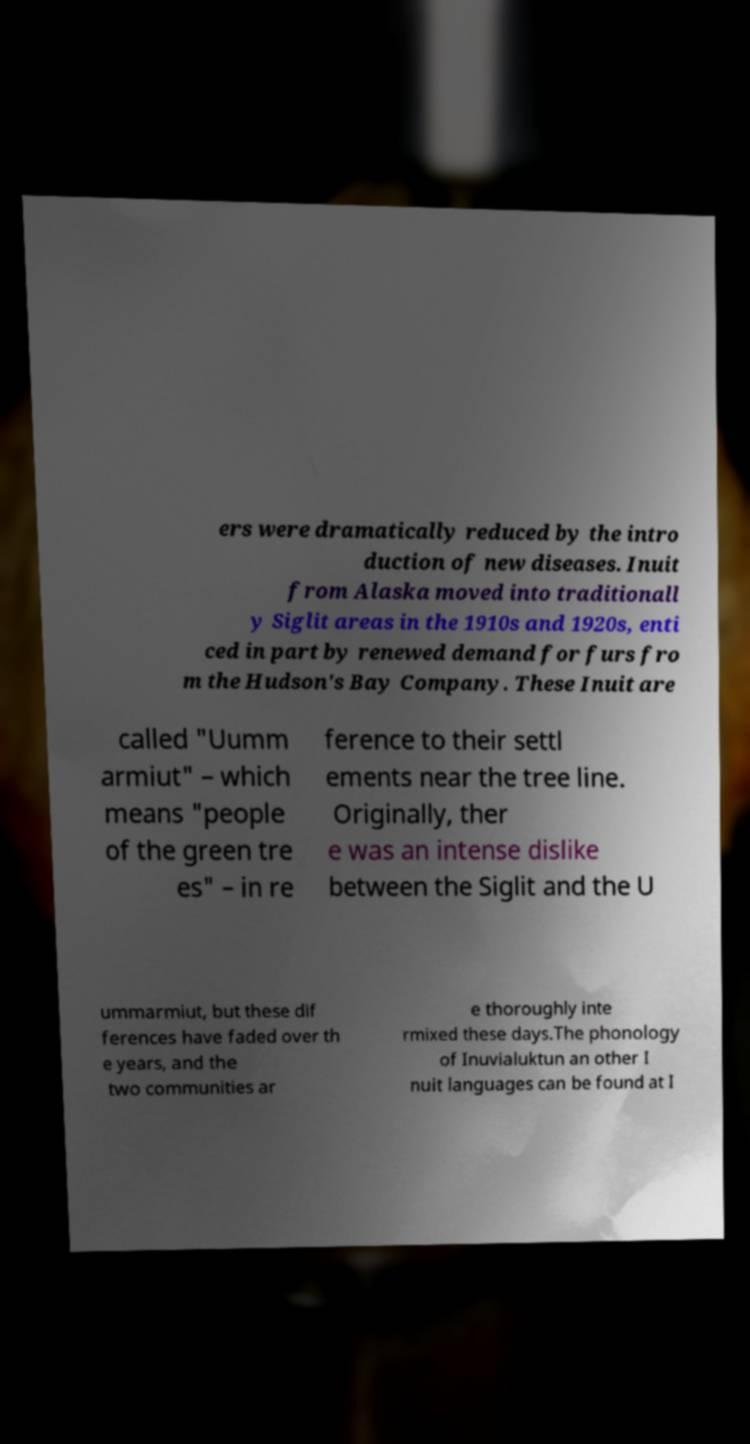Please read and relay the text visible in this image. What does it say? ers were dramatically reduced by the intro duction of new diseases. Inuit from Alaska moved into traditionall y Siglit areas in the 1910s and 1920s, enti ced in part by renewed demand for furs fro m the Hudson's Bay Company. These Inuit are called "Uumm armiut" – which means "people of the green tre es" – in re ference to their settl ements near the tree line. Originally, ther e was an intense dislike between the Siglit and the U ummarmiut, but these dif ferences have faded over th e years, and the two communities ar e thoroughly inte rmixed these days.The phonology of Inuvialuktun an other I nuit languages can be found at I 